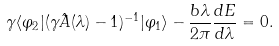<formula> <loc_0><loc_0><loc_500><loc_500>\gamma \langle \varphi _ { 2 } | ( \gamma \hat { A } ( \lambda ) - 1 ) ^ { - 1 } | \varphi _ { 1 } \rangle - \frac { b \lambda } { 2 \pi } \frac { d E } { d \lambda } = 0 .</formula> 